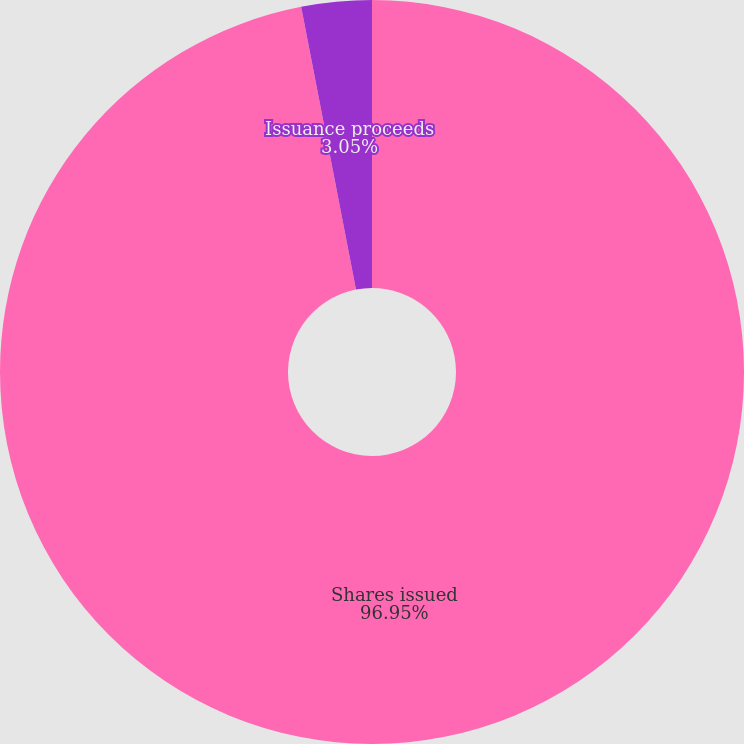Convert chart to OTSL. <chart><loc_0><loc_0><loc_500><loc_500><pie_chart><fcel>Shares issued<fcel>Issuance proceeds<nl><fcel>96.95%<fcel>3.05%<nl></chart> 